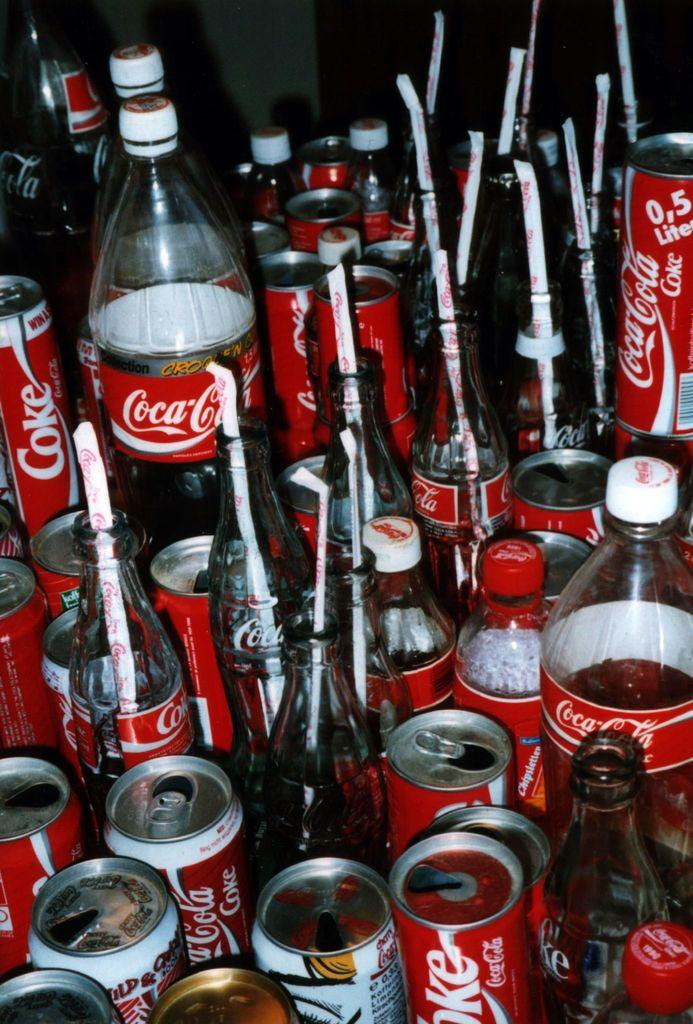What objects are present in large quantities in the image? There are many bottles in the image. What type of product do the bottles and coke tins contain? The bottles and coke tins contain Coca-Cola. What type of skirt is visible in the image? There is no skirt present in the image. How many planes are visible in the image? There are no planes present in the image. 